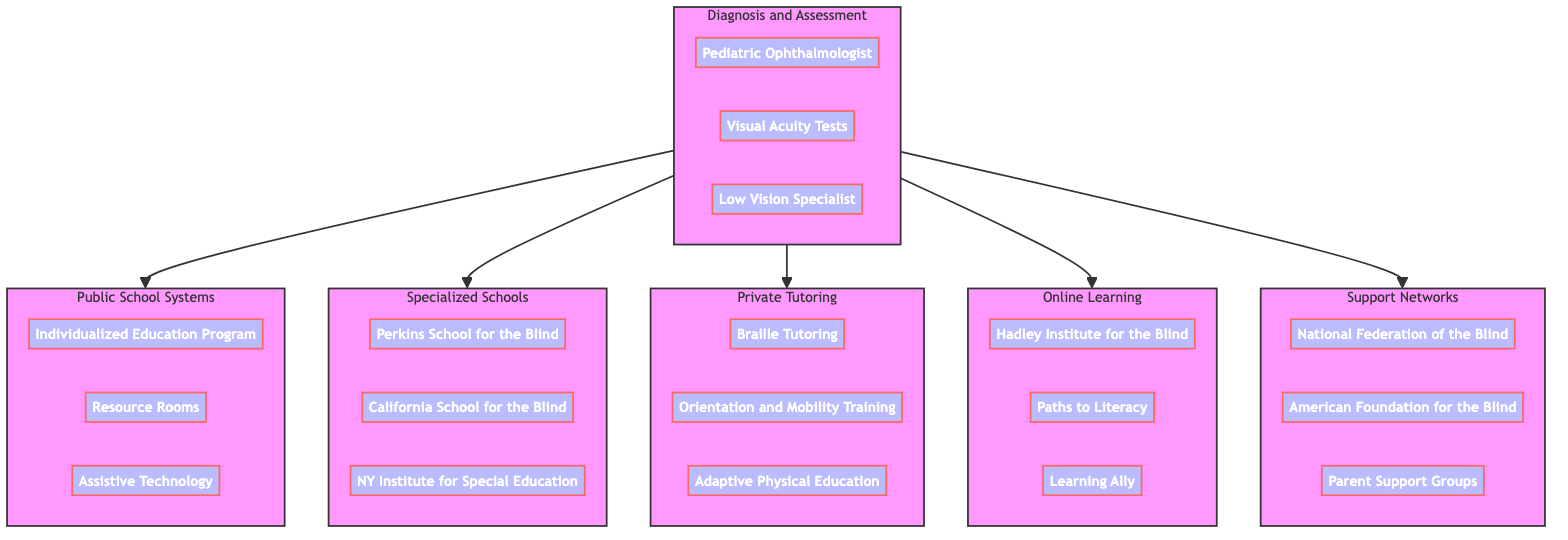What is the first step in the educational resources pathway? The diagram shows that the first step in the pathway is "Diagnosis and Initial Assessment," which includes elements necessary to determine the child's visual impairment needs.
Answer: Diagnosis and Initial Assessment How many elements are in the "Public School Systems" block? There are three elements in the "Public School Systems" block: Individualized Education Program, Resource Rooms, and Assistive Technology. Count them to get the total.
Answer: 3 Which specialized school for the blind is listed first? Based on the diagram, the first specialized school listed is the "Perkins School for the Blind," indicating its prominence or recognition in the pathway.
Answer: Perkins School for the Blind What type of tutoring is specifically mentioned in the "Private Tutoring Services" block? The "Private Tutoring Services" block specifically mentions "Braille Tutoring," indicating a focus on teaching braille to visually impaired children.
Answer: Braille Tutoring How many support networks are identified in the diagram? The diagram outlines three support networks which include the National Federation of the Blind, American Foundation for the Blind, and Parent Support Groups. Counting them gives the answer.
Answer: 3 If the pathway starts at "Diagnosis and Initial Assessment," which block follows? The flow from "Diagnosis and Initial Assessment" leads to multiple blocks. The first block that follows directly is "Public School Systems," as indicated by the connections in the diagram.
Answer: Public School Systems Which online program is listed that aids visually impaired learners? The diagram includes the "Hadley Institute for the Blind" as one of the online programs that supports visually impaired learners, showing its role in this educational pathway.
Answer: Hadley Institute for the Blind What does the "Support Networks" block include? The "Support Networks" block includes the National Federation of the Blind, American Foundation for the Blind, and Parent Support Groups, indicating the resources available for families.
Answer: National Federation of the Blind, American Foundation for the Blind, Parent Support Groups Which block contains elements related to assistive technology? The "Public School Systems" block contains the element "Assistive Technology," which indicates the resources available in public education settings for visually impaired children.
Answer: Public School Systems 